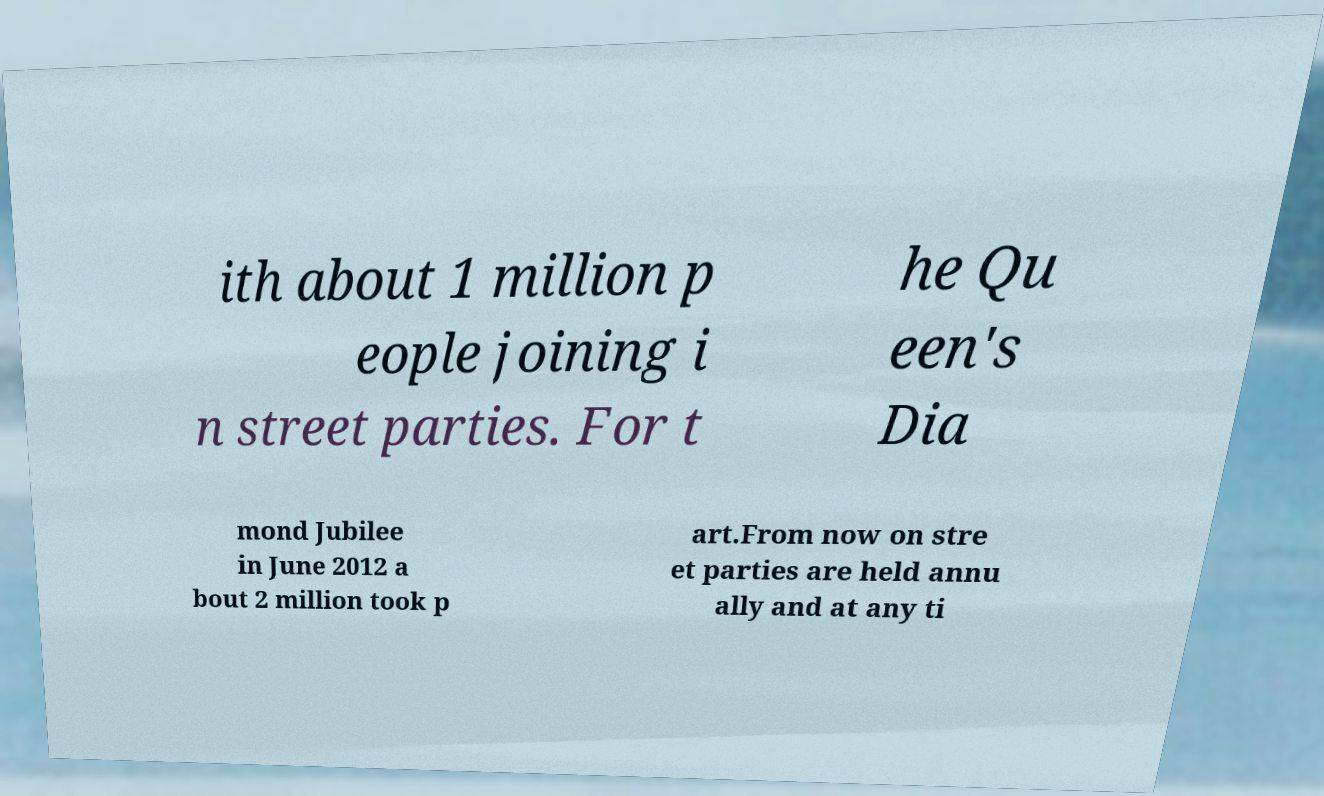Can you read and provide the text displayed in the image?This photo seems to have some interesting text. Can you extract and type it out for me? ith about 1 million p eople joining i n street parties. For t he Qu een's Dia mond Jubilee in June 2012 a bout 2 million took p art.From now on stre et parties are held annu ally and at any ti 